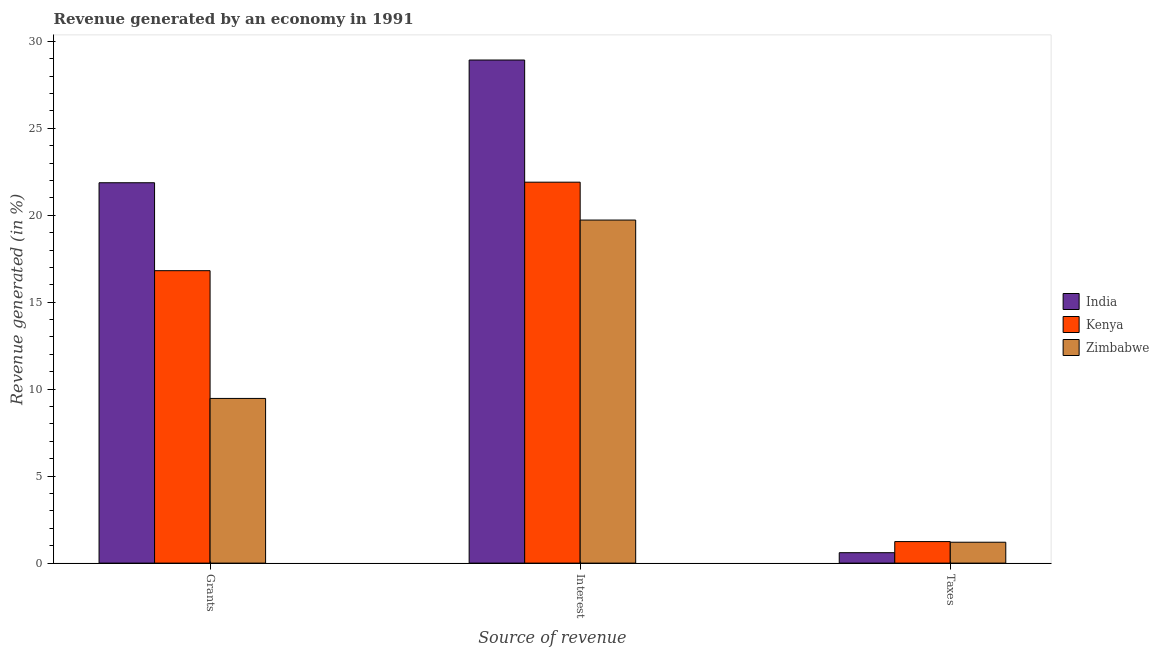How many different coloured bars are there?
Provide a succinct answer. 3. How many groups of bars are there?
Your answer should be compact. 3. Are the number of bars per tick equal to the number of legend labels?
Make the answer very short. Yes. Are the number of bars on each tick of the X-axis equal?
Your response must be concise. Yes. What is the label of the 2nd group of bars from the left?
Give a very brief answer. Interest. What is the percentage of revenue generated by grants in Kenya?
Make the answer very short. 16.81. Across all countries, what is the maximum percentage of revenue generated by interest?
Ensure brevity in your answer.  28.92. Across all countries, what is the minimum percentage of revenue generated by interest?
Make the answer very short. 19.72. In which country was the percentage of revenue generated by grants maximum?
Make the answer very short. India. In which country was the percentage of revenue generated by interest minimum?
Keep it short and to the point. Zimbabwe. What is the total percentage of revenue generated by grants in the graph?
Ensure brevity in your answer.  48.15. What is the difference between the percentage of revenue generated by interest in Zimbabwe and that in India?
Offer a very short reply. -9.2. What is the difference between the percentage of revenue generated by interest in Zimbabwe and the percentage of revenue generated by taxes in India?
Provide a succinct answer. 19.12. What is the average percentage of revenue generated by interest per country?
Keep it short and to the point. 23.52. What is the difference between the percentage of revenue generated by grants and percentage of revenue generated by taxes in India?
Give a very brief answer. 21.27. In how many countries, is the percentage of revenue generated by interest greater than 7 %?
Your answer should be compact. 3. What is the ratio of the percentage of revenue generated by taxes in India to that in Zimbabwe?
Ensure brevity in your answer.  0.5. Is the percentage of revenue generated by grants in India less than that in Kenya?
Your answer should be very brief. No. Is the difference between the percentage of revenue generated by grants in Kenya and Zimbabwe greater than the difference between the percentage of revenue generated by taxes in Kenya and Zimbabwe?
Provide a succinct answer. Yes. What is the difference between the highest and the second highest percentage of revenue generated by taxes?
Your response must be concise. 0.04. What is the difference between the highest and the lowest percentage of revenue generated by grants?
Make the answer very short. 12.4. In how many countries, is the percentage of revenue generated by interest greater than the average percentage of revenue generated by interest taken over all countries?
Your response must be concise. 1. Is the sum of the percentage of revenue generated by taxes in Kenya and Zimbabwe greater than the maximum percentage of revenue generated by interest across all countries?
Give a very brief answer. No. What does the 3rd bar from the left in Interest represents?
Offer a terse response. Zimbabwe. What does the 3rd bar from the right in Taxes represents?
Give a very brief answer. India. Is it the case that in every country, the sum of the percentage of revenue generated by grants and percentage of revenue generated by interest is greater than the percentage of revenue generated by taxes?
Give a very brief answer. Yes. How many countries are there in the graph?
Offer a very short reply. 3. What is the difference between two consecutive major ticks on the Y-axis?
Provide a succinct answer. 5. Are the values on the major ticks of Y-axis written in scientific E-notation?
Your answer should be compact. No. Where does the legend appear in the graph?
Ensure brevity in your answer.  Center right. What is the title of the graph?
Give a very brief answer. Revenue generated by an economy in 1991. What is the label or title of the X-axis?
Your answer should be very brief. Source of revenue. What is the label or title of the Y-axis?
Ensure brevity in your answer.  Revenue generated (in %). What is the Revenue generated (in %) of India in Grants?
Offer a very short reply. 21.87. What is the Revenue generated (in %) of Kenya in Grants?
Give a very brief answer. 16.81. What is the Revenue generated (in %) in Zimbabwe in Grants?
Your answer should be compact. 9.47. What is the Revenue generated (in %) in India in Interest?
Ensure brevity in your answer.  28.92. What is the Revenue generated (in %) in Kenya in Interest?
Make the answer very short. 21.9. What is the Revenue generated (in %) of Zimbabwe in Interest?
Your response must be concise. 19.72. What is the Revenue generated (in %) in India in Taxes?
Offer a terse response. 0.6. What is the Revenue generated (in %) of Kenya in Taxes?
Offer a very short reply. 1.24. What is the Revenue generated (in %) of Zimbabwe in Taxes?
Make the answer very short. 1.2. Across all Source of revenue, what is the maximum Revenue generated (in %) of India?
Ensure brevity in your answer.  28.92. Across all Source of revenue, what is the maximum Revenue generated (in %) of Kenya?
Your response must be concise. 21.9. Across all Source of revenue, what is the maximum Revenue generated (in %) of Zimbabwe?
Provide a succinct answer. 19.72. Across all Source of revenue, what is the minimum Revenue generated (in %) of India?
Your response must be concise. 0.6. Across all Source of revenue, what is the minimum Revenue generated (in %) of Kenya?
Make the answer very short. 1.24. Across all Source of revenue, what is the minimum Revenue generated (in %) in Zimbabwe?
Make the answer very short. 1.2. What is the total Revenue generated (in %) in India in the graph?
Your answer should be compact. 51.39. What is the total Revenue generated (in %) of Kenya in the graph?
Your answer should be compact. 39.95. What is the total Revenue generated (in %) of Zimbabwe in the graph?
Offer a terse response. 30.39. What is the difference between the Revenue generated (in %) in India in Grants and that in Interest?
Offer a terse response. -7.05. What is the difference between the Revenue generated (in %) of Kenya in Grants and that in Interest?
Provide a succinct answer. -5.09. What is the difference between the Revenue generated (in %) in Zimbabwe in Grants and that in Interest?
Your response must be concise. -10.26. What is the difference between the Revenue generated (in %) in India in Grants and that in Taxes?
Keep it short and to the point. 21.27. What is the difference between the Revenue generated (in %) of Kenya in Grants and that in Taxes?
Your response must be concise. 15.58. What is the difference between the Revenue generated (in %) in Zimbabwe in Grants and that in Taxes?
Offer a very short reply. 8.27. What is the difference between the Revenue generated (in %) in India in Interest and that in Taxes?
Provide a succinct answer. 28.32. What is the difference between the Revenue generated (in %) of Kenya in Interest and that in Taxes?
Give a very brief answer. 20.66. What is the difference between the Revenue generated (in %) of Zimbabwe in Interest and that in Taxes?
Provide a succinct answer. 18.52. What is the difference between the Revenue generated (in %) of India in Grants and the Revenue generated (in %) of Kenya in Interest?
Give a very brief answer. -0.03. What is the difference between the Revenue generated (in %) of India in Grants and the Revenue generated (in %) of Zimbabwe in Interest?
Ensure brevity in your answer.  2.15. What is the difference between the Revenue generated (in %) in Kenya in Grants and the Revenue generated (in %) in Zimbabwe in Interest?
Offer a terse response. -2.91. What is the difference between the Revenue generated (in %) of India in Grants and the Revenue generated (in %) of Kenya in Taxes?
Your answer should be compact. 20.63. What is the difference between the Revenue generated (in %) of India in Grants and the Revenue generated (in %) of Zimbabwe in Taxes?
Make the answer very short. 20.67. What is the difference between the Revenue generated (in %) of Kenya in Grants and the Revenue generated (in %) of Zimbabwe in Taxes?
Ensure brevity in your answer.  15.61. What is the difference between the Revenue generated (in %) of India in Interest and the Revenue generated (in %) of Kenya in Taxes?
Keep it short and to the point. 27.69. What is the difference between the Revenue generated (in %) in India in Interest and the Revenue generated (in %) in Zimbabwe in Taxes?
Give a very brief answer. 27.72. What is the difference between the Revenue generated (in %) in Kenya in Interest and the Revenue generated (in %) in Zimbabwe in Taxes?
Offer a very short reply. 20.7. What is the average Revenue generated (in %) of India per Source of revenue?
Make the answer very short. 17.13. What is the average Revenue generated (in %) in Kenya per Source of revenue?
Your answer should be very brief. 13.32. What is the average Revenue generated (in %) of Zimbabwe per Source of revenue?
Keep it short and to the point. 10.13. What is the difference between the Revenue generated (in %) of India and Revenue generated (in %) of Kenya in Grants?
Your answer should be very brief. 5.06. What is the difference between the Revenue generated (in %) of India and Revenue generated (in %) of Zimbabwe in Grants?
Ensure brevity in your answer.  12.4. What is the difference between the Revenue generated (in %) of Kenya and Revenue generated (in %) of Zimbabwe in Grants?
Provide a short and direct response. 7.35. What is the difference between the Revenue generated (in %) of India and Revenue generated (in %) of Kenya in Interest?
Offer a very short reply. 7.02. What is the difference between the Revenue generated (in %) in India and Revenue generated (in %) in Zimbabwe in Interest?
Your response must be concise. 9.2. What is the difference between the Revenue generated (in %) of Kenya and Revenue generated (in %) of Zimbabwe in Interest?
Offer a terse response. 2.18. What is the difference between the Revenue generated (in %) of India and Revenue generated (in %) of Kenya in Taxes?
Your answer should be very brief. -0.64. What is the difference between the Revenue generated (in %) in India and Revenue generated (in %) in Zimbabwe in Taxes?
Offer a very short reply. -0.6. What is the difference between the Revenue generated (in %) in Kenya and Revenue generated (in %) in Zimbabwe in Taxes?
Ensure brevity in your answer.  0.04. What is the ratio of the Revenue generated (in %) of India in Grants to that in Interest?
Make the answer very short. 0.76. What is the ratio of the Revenue generated (in %) in Kenya in Grants to that in Interest?
Your response must be concise. 0.77. What is the ratio of the Revenue generated (in %) of Zimbabwe in Grants to that in Interest?
Provide a short and direct response. 0.48. What is the ratio of the Revenue generated (in %) of India in Grants to that in Taxes?
Offer a very short reply. 36.5. What is the ratio of the Revenue generated (in %) in Kenya in Grants to that in Taxes?
Provide a succinct answer. 13.58. What is the ratio of the Revenue generated (in %) of Zimbabwe in Grants to that in Taxes?
Offer a very short reply. 7.88. What is the ratio of the Revenue generated (in %) of India in Interest to that in Taxes?
Your answer should be very brief. 48.27. What is the ratio of the Revenue generated (in %) of Kenya in Interest to that in Taxes?
Provide a short and direct response. 17.69. What is the ratio of the Revenue generated (in %) in Zimbabwe in Interest to that in Taxes?
Your answer should be very brief. 16.42. What is the difference between the highest and the second highest Revenue generated (in %) in India?
Provide a short and direct response. 7.05. What is the difference between the highest and the second highest Revenue generated (in %) in Kenya?
Keep it short and to the point. 5.09. What is the difference between the highest and the second highest Revenue generated (in %) of Zimbabwe?
Keep it short and to the point. 10.26. What is the difference between the highest and the lowest Revenue generated (in %) of India?
Keep it short and to the point. 28.32. What is the difference between the highest and the lowest Revenue generated (in %) of Kenya?
Offer a very short reply. 20.66. What is the difference between the highest and the lowest Revenue generated (in %) of Zimbabwe?
Provide a succinct answer. 18.52. 